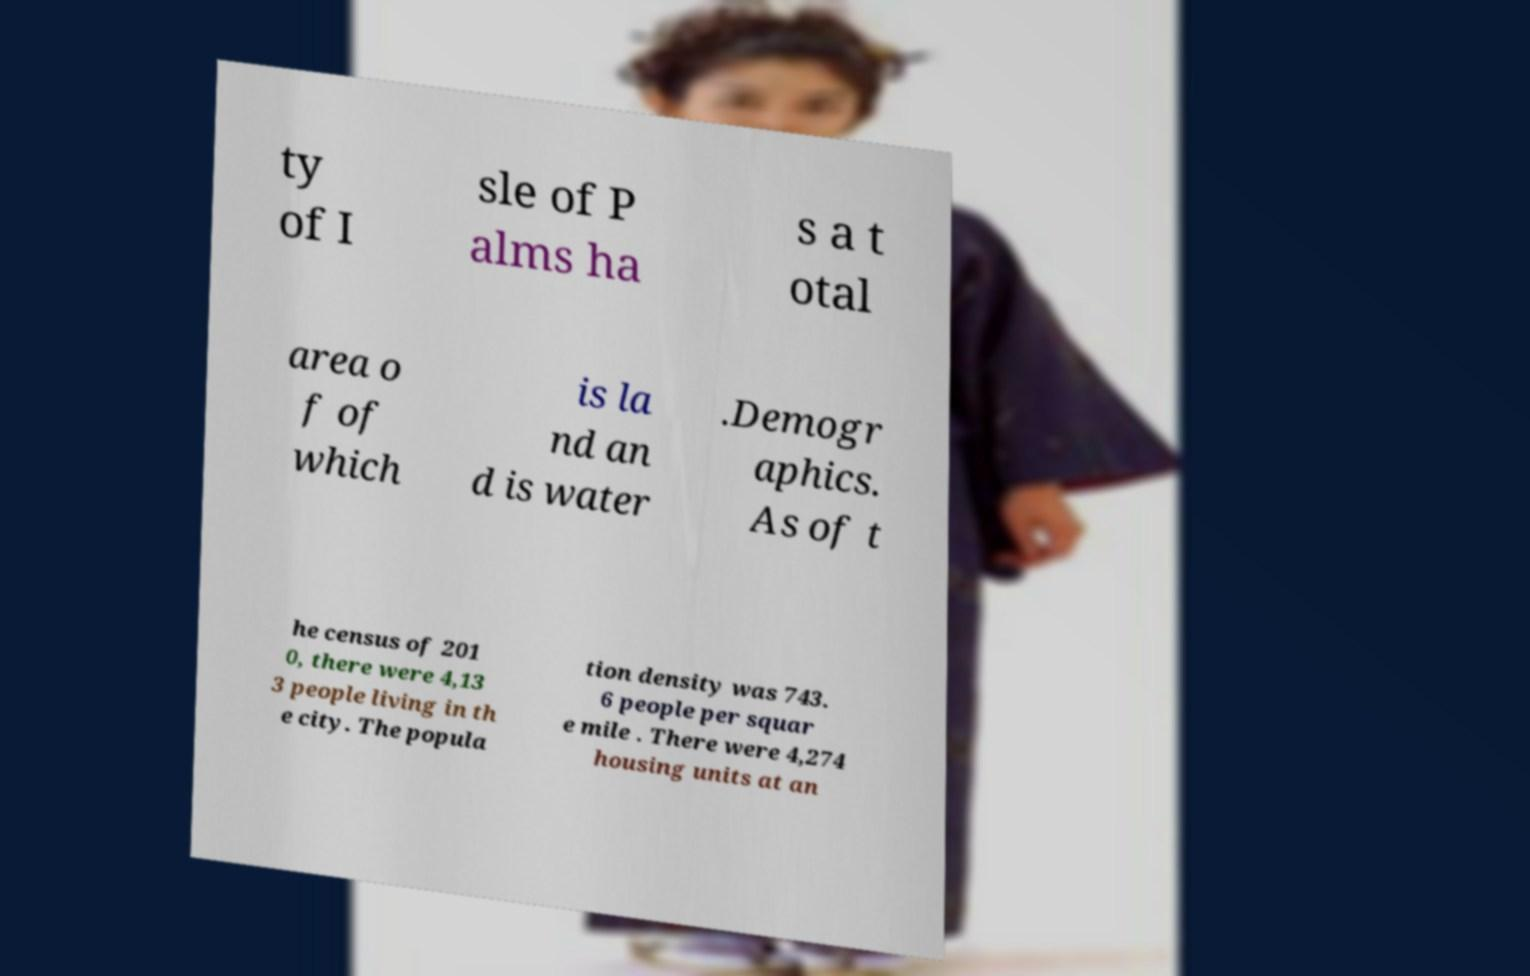Please read and relay the text visible in this image. What does it say? ty of I sle of P alms ha s a t otal area o f of which is la nd an d is water .Demogr aphics. As of t he census of 201 0, there were 4,13 3 people living in th e city. The popula tion density was 743. 6 people per squar e mile . There were 4,274 housing units at an 